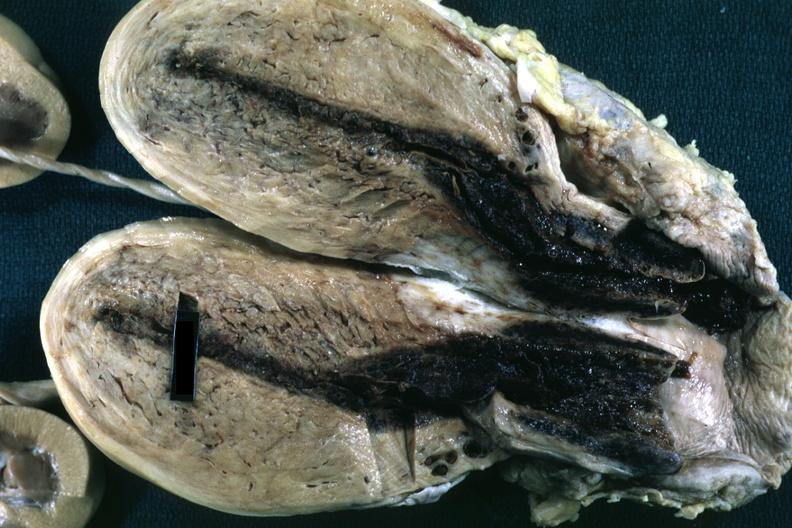s fixed tissue opened uterus with blood clot in cervical canal and small endometrial cavity?
Answer the question using a single word or phrase. Yes 